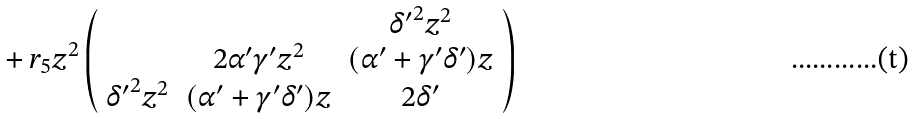<formula> <loc_0><loc_0><loc_500><loc_500>\, + \, r _ { 5 } z ^ { 2 } \left ( \begin{array} { c c c } & & { \delta ^ { \prime } } ^ { 2 } z ^ { 2 } \\ & 2 { \alpha ^ { \prime } } { \gamma ^ { \prime } } z ^ { 2 } & ( { \alpha ^ { \prime } } + { \gamma ^ { \prime } } { \delta ^ { \prime } } ) z \\ { \delta ^ { \prime } } ^ { 2 } z ^ { 2 } & ( { \alpha ^ { \prime } } + { \gamma ^ { \prime } } { \delta ^ { \prime } } ) z & 2 { \delta ^ { \prime } } \\ \end{array} \right )</formula> 